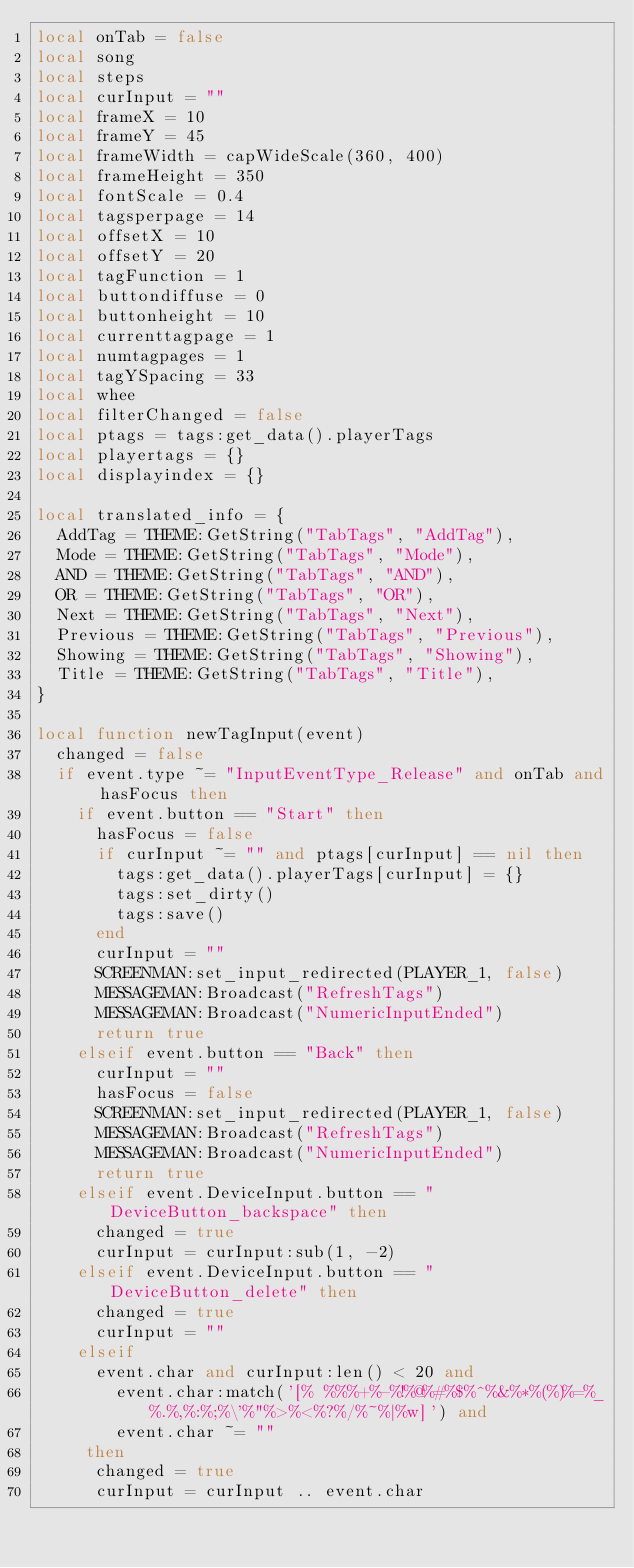<code> <loc_0><loc_0><loc_500><loc_500><_Lua_>local onTab = false
local song
local steps
local curInput = ""
local frameX = 10
local frameY = 45
local frameWidth = capWideScale(360, 400)
local frameHeight = 350
local fontScale = 0.4
local tagsperpage = 14
local offsetX = 10
local offsetY = 20
local tagFunction = 1
local buttondiffuse = 0
local buttonheight = 10
local currenttagpage = 1
local numtagpages = 1
local tagYSpacing = 33
local whee
local filterChanged = false
local ptags = tags:get_data().playerTags
local playertags = {}
local displayindex = {}

local translated_info = {
	AddTag = THEME:GetString("TabTags", "AddTag"),
	Mode = THEME:GetString("TabTags", "Mode"),
	AND = THEME:GetString("TabTags", "AND"),
	OR = THEME:GetString("TabTags", "OR"),
	Next = THEME:GetString("TabTags", "Next"),
	Previous = THEME:GetString("TabTags", "Previous"),
	Showing = THEME:GetString("TabTags", "Showing"),
	Title = THEME:GetString("TabTags", "Title"),
}

local function newTagInput(event)
	changed = false
	if event.type ~= "InputEventType_Release" and onTab and hasFocus then
		if event.button == "Start" then
			hasFocus = false
			if curInput ~= "" and ptags[curInput] == nil then
				tags:get_data().playerTags[curInput] = {}
				tags:set_dirty()
				tags:save()
			end
			curInput = ""
			SCREENMAN:set_input_redirected(PLAYER_1, false)
			MESSAGEMAN:Broadcast("RefreshTags")
			MESSAGEMAN:Broadcast("NumericInputEnded")
			return true
		elseif event.button == "Back" then
			curInput = ""
			hasFocus = false
			SCREENMAN:set_input_redirected(PLAYER_1, false)
			MESSAGEMAN:Broadcast("RefreshTags")
			MESSAGEMAN:Broadcast("NumericInputEnded")
			return true
		elseif event.DeviceInput.button == "DeviceButton_backspace" then
			changed = true
			curInput = curInput:sub(1, -2)
		elseif event.DeviceInput.button == "DeviceButton_delete" then
			changed = true
			curInput = ""
		elseif
			event.char and curInput:len() < 20 and
				event.char:match('[% %%%+%-%!%@%#%$%^%&%*%(%)%=%_%.%,%:%;%\'%"%>%<%?%/%~%|%w]') and
				event.char ~= ""
		 then
			changed = true
			curInput = curInput .. event.char</code> 